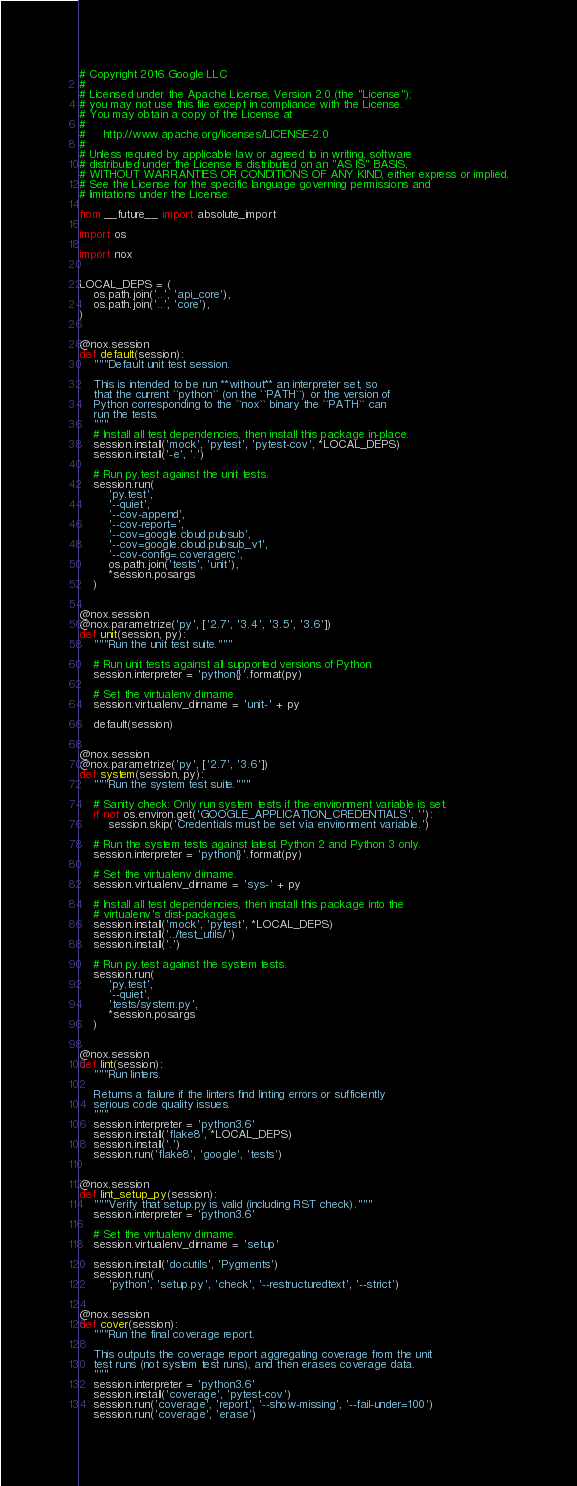<code> <loc_0><loc_0><loc_500><loc_500><_Python_># Copyright 2016 Google LLC
#
# Licensed under the Apache License, Version 2.0 (the "License");
# you may not use this file except in compliance with the License.
# You may obtain a copy of the License at
#
#     http://www.apache.org/licenses/LICENSE-2.0
#
# Unless required by applicable law or agreed to in writing, software
# distributed under the License is distributed on an "AS IS" BASIS,
# WITHOUT WARRANTIES OR CONDITIONS OF ANY KIND, either express or implied.
# See the License for the specific language governing permissions and
# limitations under the License.

from __future__ import absolute_import

import os

import nox


LOCAL_DEPS = (
    os.path.join('..', 'api_core'),
    os.path.join('..', 'core'),
)


@nox.session
def default(session):
    """Default unit test session.

    This is intended to be run **without** an interpreter set, so
    that the current ``python`` (on the ``PATH``) or the version of
    Python corresponding to the ``nox`` binary the ``PATH`` can
    run the tests.
    """
    # Install all test dependencies, then install this package in-place.
    session.install('mock', 'pytest', 'pytest-cov', *LOCAL_DEPS)
    session.install('-e', '.')

    # Run py.test against the unit tests.
    session.run(
        'py.test',
        '--quiet',
        '--cov-append',
        '--cov-report=',
        '--cov=google.cloud.pubsub',
        '--cov=google.cloud.pubsub_v1',
        '--cov-config=.coveragerc',
        os.path.join('tests', 'unit'),
        *session.posargs
    )


@nox.session
@nox.parametrize('py', ['2.7', '3.4', '3.5', '3.6'])
def unit(session, py):
    """Run the unit test suite."""

    # Run unit tests against all supported versions of Python.
    session.interpreter = 'python{}'.format(py)

    # Set the virtualenv dirname.
    session.virtualenv_dirname = 'unit-' + py

    default(session)


@nox.session
@nox.parametrize('py', ['2.7', '3.6'])
def system(session, py):
    """Run the system test suite."""

    # Sanity check: Only run system tests if the environment variable is set.
    if not os.environ.get('GOOGLE_APPLICATION_CREDENTIALS', ''):
        session.skip('Credentials must be set via environment variable.')

    # Run the system tests against latest Python 2 and Python 3 only.
    session.interpreter = 'python{}'.format(py)

    # Set the virtualenv dirname.
    session.virtualenv_dirname = 'sys-' + py

    # Install all test dependencies, then install this package into the
    # virtualenv's dist-packages.
    session.install('mock', 'pytest', *LOCAL_DEPS)
    session.install('../test_utils/')
    session.install('.')

    # Run py.test against the system tests.
    session.run(
        'py.test',
        '--quiet',
        'tests/system.py',
        *session.posargs
    )


@nox.session
def lint(session):
    """Run linters.

    Returns a failure if the linters find linting errors or sufficiently
    serious code quality issues.
    """
    session.interpreter = 'python3.6'
    session.install('flake8', *LOCAL_DEPS)
    session.install('.')
    session.run('flake8', 'google', 'tests')


@nox.session
def lint_setup_py(session):
    """Verify that setup.py is valid (including RST check)."""
    session.interpreter = 'python3.6'

    # Set the virtualenv dirname.
    session.virtualenv_dirname = 'setup'

    session.install('docutils', 'Pygments')
    session.run(
        'python', 'setup.py', 'check', '--restructuredtext', '--strict')


@nox.session
def cover(session):
    """Run the final coverage report.

    This outputs the coverage report aggregating coverage from the unit
    test runs (not system test runs), and then erases coverage data.
    """
    session.interpreter = 'python3.6'
    session.install('coverage', 'pytest-cov')
    session.run('coverage', 'report', '--show-missing', '--fail-under=100')
    session.run('coverage', 'erase')
</code> 